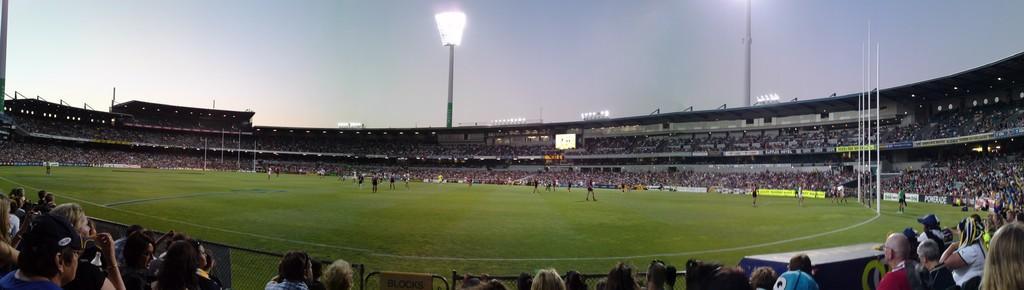Could you give a brief overview of what you see in this image? In the foreground of this image, there are people standing and walking on the grass land. Around which there is stadium, where people are sitting and standing. We can also see poles, lights and the sky. 